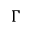Convert formula to latex. <formula><loc_0><loc_0><loc_500><loc_500>\Gamma</formula> 